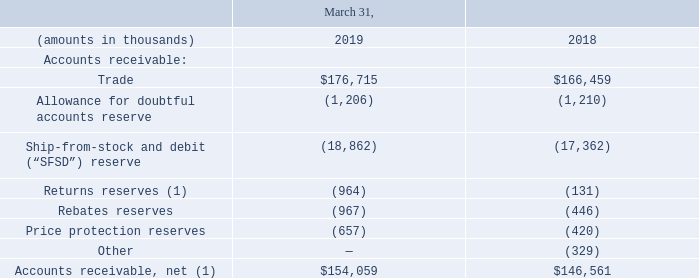Note 13: Supplemental Balance Sheets and Statements of Operations Detail
(1) Fiscal year ended March 31, 2018 adjusted due to the adoption of ASC 606.
Which years does the table provide information for the Supplemental Balance Sheets and Statements of Operations Detail for the company? 2019, 2018. What was the amount of trade in 2019?
Answer scale should be: thousand. 176,715. What was the Allowance for doubtful accounts reserve in 2018?
Answer scale should be: thousand. (1,210). Which years did the net accounts receivables exceed $150,000 thousand? 2019
Answer: 1. What was the change in the Returns reserves between 2018 and 2019?
Answer scale should be: thousand. -964-(-131)
Answer: -833. What was the percentage change in the amount of trade between 2018 and 2019?
Answer scale should be: percent. (176,715-166,459)/166,459
Answer: 6.16. 